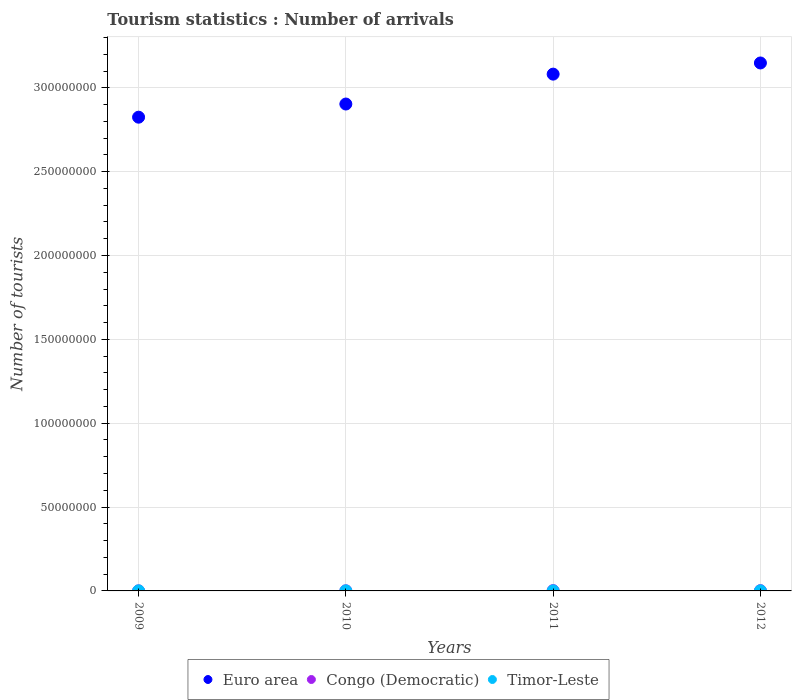What is the number of tourist arrivals in Congo (Democratic) in 2012?
Provide a succinct answer. 1.67e+05. Across all years, what is the maximum number of tourist arrivals in Congo (Democratic)?
Your answer should be compact. 1.86e+05. Across all years, what is the minimum number of tourist arrivals in Congo (Democratic)?
Your answer should be very brief. 5.30e+04. In which year was the number of tourist arrivals in Timor-Leste maximum?
Offer a terse response. 2012. In which year was the number of tourist arrivals in Congo (Democratic) minimum?
Ensure brevity in your answer.  2009. What is the total number of tourist arrivals in Euro area in the graph?
Make the answer very short. 1.20e+09. What is the difference between the number of tourist arrivals in Euro area in 2010 and that in 2012?
Give a very brief answer. -2.45e+07. What is the difference between the number of tourist arrivals in Euro area in 2012 and the number of tourist arrivals in Timor-Leste in 2009?
Provide a succinct answer. 3.15e+08. What is the average number of tourist arrivals in Timor-Leste per year?
Offer a terse response. 4.82e+04. In the year 2011, what is the difference between the number of tourist arrivals in Euro area and number of tourist arrivals in Congo (Democratic)?
Make the answer very short. 3.08e+08. What is the ratio of the number of tourist arrivals in Euro area in 2010 to that in 2012?
Your answer should be very brief. 0.92. Is the difference between the number of tourist arrivals in Euro area in 2010 and 2011 greater than the difference between the number of tourist arrivals in Congo (Democratic) in 2010 and 2011?
Give a very brief answer. No. What is the difference between the highest and the second highest number of tourist arrivals in Timor-Leste?
Offer a very short reply. 7000. What is the difference between the highest and the lowest number of tourist arrivals in Euro area?
Provide a succinct answer. 3.23e+07. In how many years, is the number of tourist arrivals in Euro area greater than the average number of tourist arrivals in Euro area taken over all years?
Your answer should be compact. 2. Is the sum of the number of tourist arrivals in Congo (Democratic) in 2009 and 2010 greater than the maximum number of tourist arrivals in Timor-Leste across all years?
Provide a succinct answer. Yes. Is it the case that in every year, the sum of the number of tourist arrivals in Congo (Democratic) and number of tourist arrivals in Timor-Leste  is greater than the number of tourist arrivals in Euro area?
Offer a terse response. No. How many dotlines are there?
Your answer should be compact. 3. What is the difference between two consecutive major ticks on the Y-axis?
Your answer should be very brief. 5.00e+07. Where does the legend appear in the graph?
Provide a succinct answer. Bottom center. How are the legend labels stacked?
Ensure brevity in your answer.  Horizontal. What is the title of the graph?
Provide a succinct answer. Tourism statistics : Number of arrivals. Does "Burkina Faso" appear as one of the legend labels in the graph?
Your answer should be very brief. No. What is the label or title of the Y-axis?
Make the answer very short. Number of tourists. What is the Number of tourists in Euro area in 2009?
Give a very brief answer. 2.82e+08. What is the Number of tourists of Congo (Democratic) in 2009?
Your answer should be very brief. 5.30e+04. What is the Number of tourists of Timor-Leste in 2009?
Your answer should be very brief. 4.40e+04. What is the Number of tourists of Euro area in 2010?
Give a very brief answer. 2.90e+08. What is the Number of tourists of Congo (Democratic) in 2010?
Your answer should be compact. 8.10e+04. What is the Number of tourists of Euro area in 2011?
Keep it short and to the point. 3.08e+08. What is the Number of tourists in Congo (Democratic) in 2011?
Offer a terse response. 1.86e+05. What is the Number of tourists in Timor-Leste in 2011?
Keep it short and to the point. 5.10e+04. What is the Number of tourists in Euro area in 2012?
Provide a succinct answer. 3.15e+08. What is the Number of tourists in Congo (Democratic) in 2012?
Provide a short and direct response. 1.67e+05. What is the Number of tourists in Timor-Leste in 2012?
Give a very brief answer. 5.80e+04. Across all years, what is the maximum Number of tourists of Euro area?
Ensure brevity in your answer.  3.15e+08. Across all years, what is the maximum Number of tourists in Congo (Democratic)?
Provide a short and direct response. 1.86e+05. Across all years, what is the maximum Number of tourists in Timor-Leste?
Offer a terse response. 5.80e+04. Across all years, what is the minimum Number of tourists in Euro area?
Give a very brief answer. 2.82e+08. Across all years, what is the minimum Number of tourists of Congo (Democratic)?
Ensure brevity in your answer.  5.30e+04. Across all years, what is the minimum Number of tourists in Timor-Leste?
Your response must be concise. 4.00e+04. What is the total Number of tourists of Euro area in the graph?
Offer a very short reply. 1.20e+09. What is the total Number of tourists in Congo (Democratic) in the graph?
Give a very brief answer. 4.87e+05. What is the total Number of tourists in Timor-Leste in the graph?
Offer a terse response. 1.93e+05. What is the difference between the Number of tourists in Euro area in 2009 and that in 2010?
Provide a short and direct response. -7.85e+06. What is the difference between the Number of tourists in Congo (Democratic) in 2009 and that in 2010?
Keep it short and to the point. -2.80e+04. What is the difference between the Number of tourists in Timor-Leste in 2009 and that in 2010?
Provide a succinct answer. 4000. What is the difference between the Number of tourists in Euro area in 2009 and that in 2011?
Offer a terse response. -2.57e+07. What is the difference between the Number of tourists of Congo (Democratic) in 2009 and that in 2011?
Give a very brief answer. -1.33e+05. What is the difference between the Number of tourists of Timor-Leste in 2009 and that in 2011?
Provide a short and direct response. -7000. What is the difference between the Number of tourists in Euro area in 2009 and that in 2012?
Offer a very short reply. -3.23e+07. What is the difference between the Number of tourists of Congo (Democratic) in 2009 and that in 2012?
Provide a succinct answer. -1.14e+05. What is the difference between the Number of tourists in Timor-Leste in 2009 and that in 2012?
Ensure brevity in your answer.  -1.40e+04. What is the difference between the Number of tourists of Euro area in 2010 and that in 2011?
Give a very brief answer. -1.78e+07. What is the difference between the Number of tourists in Congo (Democratic) in 2010 and that in 2011?
Give a very brief answer. -1.05e+05. What is the difference between the Number of tourists of Timor-Leste in 2010 and that in 2011?
Offer a terse response. -1.10e+04. What is the difference between the Number of tourists in Euro area in 2010 and that in 2012?
Your response must be concise. -2.45e+07. What is the difference between the Number of tourists of Congo (Democratic) in 2010 and that in 2012?
Offer a very short reply. -8.60e+04. What is the difference between the Number of tourists in Timor-Leste in 2010 and that in 2012?
Offer a very short reply. -1.80e+04. What is the difference between the Number of tourists in Euro area in 2011 and that in 2012?
Offer a terse response. -6.66e+06. What is the difference between the Number of tourists in Congo (Democratic) in 2011 and that in 2012?
Your answer should be compact. 1.90e+04. What is the difference between the Number of tourists in Timor-Leste in 2011 and that in 2012?
Offer a very short reply. -7000. What is the difference between the Number of tourists of Euro area in 2009 and the Number of tourists of Congo (Democratic) in 2010?
Your answer should be compact. 2.82e+08. What is the difference between the Number of tourists in Euro area in 2009 and the Number of tourists in Timor-Leste in 2010?
Your answer should be very brief. 2.82e+08. What is the difference between the Number of tourists in Congo (Democratic) in 2009 and the Number of tourists in Timor-Leste in 2010?
Provide a short and direct response. 1.30e+04. What is the difference between the Number of tourists of Euro area in 2009 and the Number of tourists of Congo (Democratic) in 2011?
Offer a terse response. 2.82e+08. What is the difference between the Number of tourists of Euro area in 2009 and the Number of tourists of Timor-Leste in 2011?
Provide a succinct answer. 2.82e+08. What is the difference between the Number of tourists of Euro area in 2009 and the Number of tourists of Congo (Democratic) in 2012?
Offer a very short reply. 2.82e+08. What is the difference between the Number of tourists of Euro area in 2009 and the Number of tourists of Timor-Leste in 2012?
Make the answer very short. 2.82e+08. What is the difference between the Number of tourists of Congo (Democratic) in 2009 and the Number of tourists of Timor-Leste in 2012?
Offer a terse response. -5000. What is the difference between the Number of tourists of Euro area in 2010 and the Number of tourists of Congo (Democratic) in 2011?
Offer a very short reply. 2.90e+08. What is the difference between the Number of tourists in Euro area in 2010 and the Number of tourists in Timor-Leste in 2011?
Provide a succinct answer. 2.90e+08. What is the difference between the Number of tourists of Congo (Democratic) in 2010 and the Number of tourists of Timor-Leste in 2011?
Ensure brevity in your answer.  3.00e+04. What is the difference between the Number of tourists in Euro area in 2010 and the Number of tourists in Congo (Democratic) in 2012?
Your response must be concise. 2.90e+08. What is the difference between the Number of tourists of Euro area in 2010 and the Number of tourists of Timor-Leste in 2012?
Offer a terse response. 2.90e+08. What is the difference between the Number of tourists in Congo (Democratic) in 2010 and the Number of tourists in Timor-Leste in 2012?
Make the answer very short. 2.30e+04. What is the difference between the Number of tourists in Euro area in 2011 and the Number of tourists in Congo (Democratic) in 2012?
Your answer should be compact. 3.08e+08. What is the difference between the Number of tourists in Euro area in 2011 and the Number of tourists in Timor-Leste in 2012?
Offer a very short reply. 3.08e+08. What is the difference between the Number of tourists in Congo (Democratic) in 2011 and the Number of tourists in Timor-Leste in 2012?
Offer a terse response. 1.28e+05. What is the average Number of tourists in Euro area per year?
Make the answer very short. 2.99e+08. What is the average Number of tourists of Congo (Democratic) per year?
Provide a succinct answer. 1.22e+05. What is the average Number of tourists of Timor-Leste per year?
Provide a succinct answer. 4.82e+04. In the year 2009, what is the difference between the Number of tourists of Euro area and Number of tourists of Congo (Democratic)?
Your response must be concise. 2.82e+08. In the year 2009, what is the difference between the Number of tourists of Euro area and Number of tourists of Timor-Leste?
Ensure brevity in your answer.  2.82e+08. In the year 2009, what is the difference between the Number of tourists in Congo (Democratic) and Number of tourists in Timor-Leste?
Provide a succinct answer. 9000. In the year 2010, what is the difference between the Number of tourists of Euro area and Number of tourists of Congo (Democratic)?
Offer a very short reply. 2.90e+08. In the year 2010, what is the difference between the Number of tourists in Euro area and Number of tourists in Timor-Leste?
Your answer should be compact. 2.90e+08. In the year 2010, what is the difference between the Number of tourists of Congo (Democratic) and Number of tourists of Timor-Leste?
Your response must be concise. 4.10e+04. In the year 2011, what is the difference between the Number of tourists of Euro area and Number of tourists of Congo (Democratic)?
Your answer should be compact. 3.08e+08. In the year 2011, what is the difference between the Number of tourists of Euro area and Number of tourists of Timor-Leste?
Your answer should be very brief. 3.08e+08. In the year 2011, what is the difference between the Number of tourists of Congo (Democratic) and Number of tourists of Timor-Leste?
Offer a very short reply. 1.35e+05. In the year 2012, what is the difference between the Number of tourists in Euro area and Number of tourists in Congo (Democratic)?
Offer a very short reply. 3.15e+08. In the year 2012, what is the difference between the Number of tourists in Euro area and Number of tourists in Timor-Leste?
Your response must be concise. 3.15e+08. In the year 2012, what is the difference between the Number of tourists in Congo (Democratic) and Number of tourists in Timor-Leste?
Ensure brevity in your answer.  1.09e+05. What is the ratio of the Number of tourists in Congo (Democratic) in 2009 to that in 2010?
Your answer should be very brief. 0.65. What is the ratio of the Number of tourists of Euro area in 2009 to that in 2011?
Provide a short and direct response. 0.92. What is the ratio of the Number of tourists in Congo (Democratic) in 2009 to that in 2011?
Offer a very short reply. 0.28. What is the ratio of the Number of tourists of Timor-Leste in 2009 to that in 2011?
Your answer should be very brief. 0.86. What is the ratio of the Number of tourists in Euro area in 2009 to that in 2012?
Give a very brief answer. 0.9. What is the ratio of the Number of tourists in Congo (Democratic) in 2009 to that in 2012?
Provide a short and direct response. 0.32. What is the ratio of the Number of tourists in Timor-Leste in 2009 to that in 2012?
Your answer should be compact. 0.76. What is the ratio of the Number of tourists in Euro area in 2010 to that in 2011?
Your answer should be very brief. 0.94. What is the ratio of the Number of tourists in Congo (Democratic) in 2010 to that in 2011?
Make the answer very short. 0.44. What is the ratio of the Number of tourists in Timor-Leste in 2010 to that in 2011?
Offer a terse response. 0.78. What is the ratio of the Number of tourists in Euro area in 2010 to that in 2012?
Offer a terse response. 0.92. What is the ratio of the Number of tourists in Congo (Democratic) in 2010 to that in 2012?
Your answer should be compact. 0.48. What is the ratio of the Number of tourists in Timor-Leste in 2010 to that in 2012?
Your answer should be very brief. 0.69. What is the ratio of the Number of tourists of Euro area in 2011 to that in 2012?
Offer a very short reply. 0.98. What is the ratio of the Number of tourists of Congo (Democratic) in 2011 to that in 2012?
Keep it short and to the point. 1.11. What is the ratio of the Number of tourists of Timor-Leste in 2011 to that in 2012?
Your answer should be very brief. 0.88. What is the difference between the highest and the second highest Number of tourists of Euro area?
Offer a very short reply. 6.66e+06. What is the difference between the highest and the second highest Number of tourists of Congo (Democratic)?
Your answer should be compact. 1.90e+04. What is the difference between the highest and the second highest Number of tourists in Timor-Leste?
Your response must be concise. 7000. What is the difference between the highest and the lowest Number of tourists in Euro area?
Make the answer very short. 3.23e+07. What is the difference between the highest and the lowest Number of tourists in Congo (Democratic)?
Ensure brevity in your answer.  1.33e+05. What is the difference between the highest and the lowest Number of tourists of Timor-Leste?
Your answer should be very brief. 1.80e+04. 